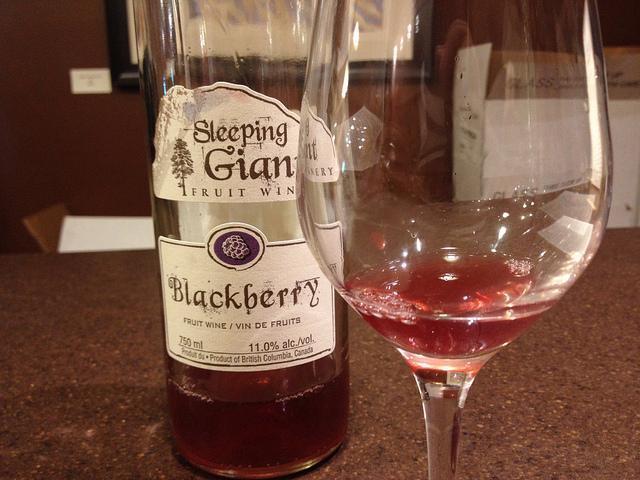What is the percent of alcohol?
Choose the right answer from the provided options to respond to the question.
Options: Five, 11, 60, 80. 11. 